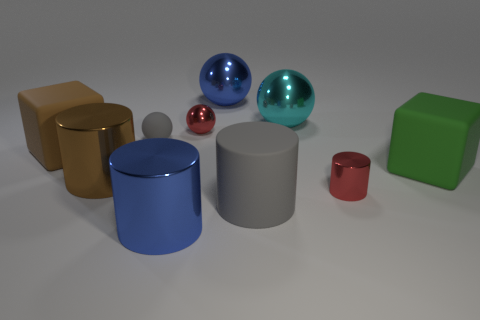Subtract all cylinders. How many objects are left? 6 Subtract all large cyan metallic spheres. Subtract all green cylinders. How many objects are left? 9 Add 9 blue shiny cylinders. How many blue shiny cylinders are left? 10 Add 2 big gray matte things. How many big gray matte things exist? 3 Subtract 0 cyan cubes. How many objects are left? 10 